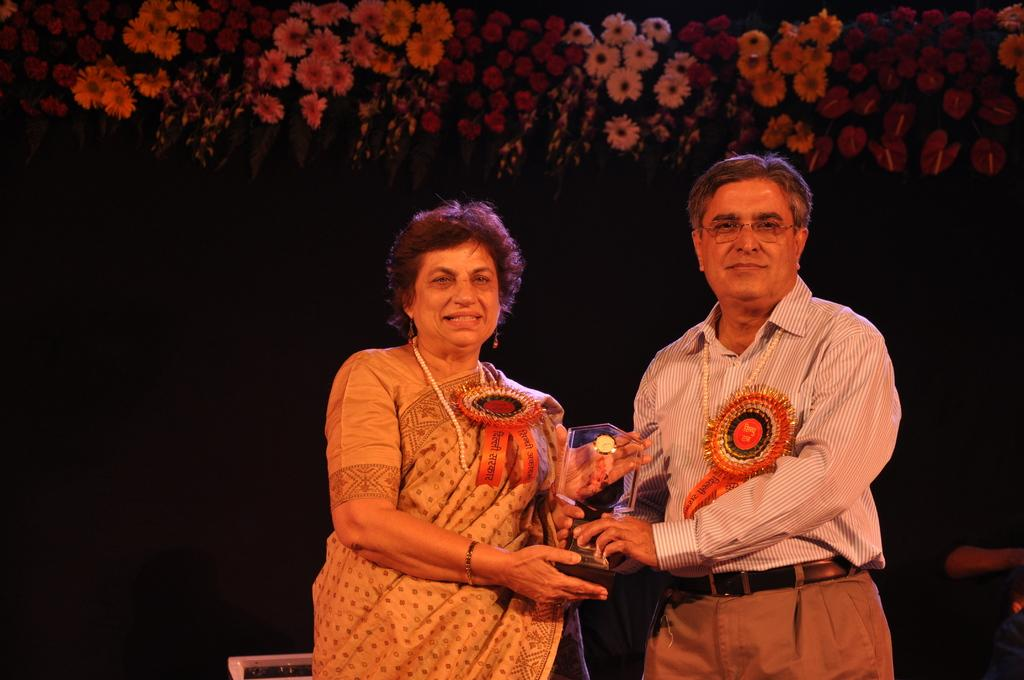What can be seen in the foreground of the image? There are persons standing in the front of the image. What are the persons holding in the image? The persons are holding objects. What is the facial expression of the persons in the image? The persons are smiling. What type of vegetation can be seen in the background of the image? There are flowers in the background of the image. Can you describe the color and location of an object in the background? There is an object in the background that is white in color. What type of hate can be seen on the faces of the persons in the image? There is no hate present on the faces of the persons in the image; they are smiling. Can you describe the doll in the image? There is no doll present in the image. What is the condition of the foot of the person in the image? There is no mention of a foot or any foot-related condition in the image. 